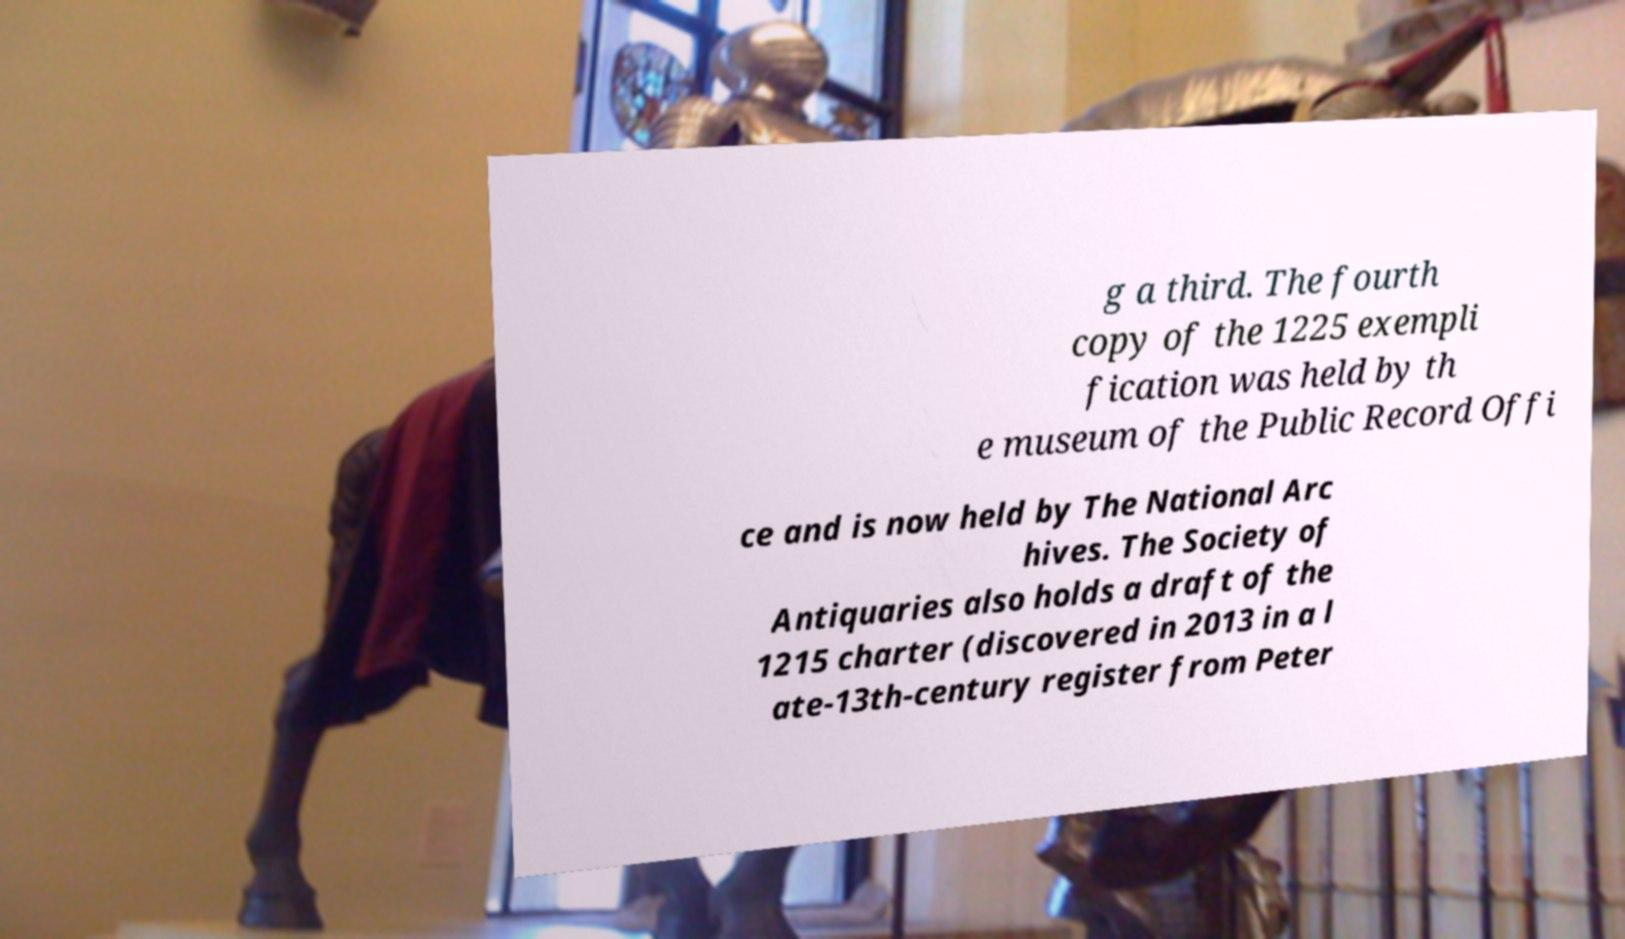Can you read and provide the text displayed in the image?This photo seems to have some interesting text. Can you extract and type it out for me? g a third. The fourth copy of the 1225 exempli fication was held by th e museum of the Public Record Offi ce and is now held by The National Arc hives. The Society of Antiquaries also holds a draft of the 1215 charter (discovered in 2013 in a l ate-13th-century register from Peter 